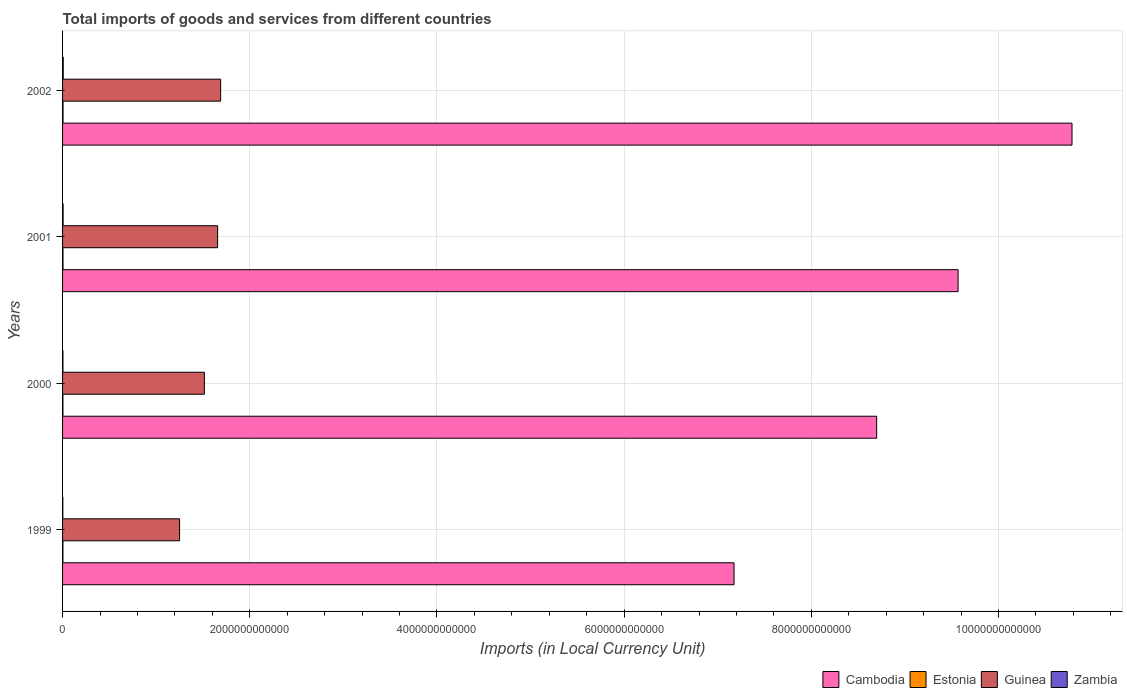How many different coloured bars are there?
Your answer should be very brief. 4. Are the number of bars per tick equal to the number of legend labels?
Your answer should be very brief. Yes. How many bars are there on the 1st tick from the top?
Provide a succinct answer. 4. What is the label of the 3rd group of bars from the top?
Your response must be concise. 2000. In how many cases, is the number of bars for a given year not equal to the number of legend labels?
Your response must be concise. 0. What is the Amount of goods and services imports in Zambia in 1999?
Give a very brief answer. 2.82e+09. Across all years, what is the maximum Amount of goods and services imports in Guinea?
Offer a very short reply. 1.69e+12. Across all years, what is the minimum Amount of goods and services imports in Estonia?
Your answer should be compact. 4.00e+09. In which year was the Amount of goods and services imports in Cambodia maximum?
Keep it short and to the point. 2002. What is the total Amount of goods and services imports in Estonia in the graph?
Your response must be concise. 1.77e+1. What is the difference between the Amount of goods and services imports in Estonia in 1999 and that in 2002?
Keep it short and to the point. -1.10e+09. What is the difference between the Amount of goods and services imports in Estonia in 1999 and the Amount of goods and services imports in Guinea in 2001?
Keep it short and to the point. -1.65e+12. What is the average Amount of goods and services imports in Zambia per year?
Keep it short and to the point. 4.93e+09. In the year 2001, what is the difference between the Amount of goods and services imports in Guinea and Amount of goods and services imports in Estonia?
Your answer should be compact. 1.65e+12. What is the ratio of the Amount of goods and services imports in Guinea in 1999 to that in 2002?
Provide a short and direct response. 0.74. Is the Amount of goods and services imports in Guinea in 1999 less than that in 2000?
Ensure brevity in your answer.  Yes. Is the difference between the Amount of goods and services imports in Guinea in 1999 and 2002 greater than the difference between the Amount of goods and services imports in Estonia in 1999 and 2002?
Your answer should be very brief. No. What is the difference between the highest and the second highest Amount of goods and services imports in Zambia?
Your answer should be very brief. 1.12e+09. What is the difference between the highest and the lowest Amount of goods and services imports in Cambodia?
Your answer should be very brief. 3.61e+12. In how many years, is the Amount of goods and services imports in Zambia greater than the average Amount of goods and services imports in Zambia taken over all years?
Offer a very short reply. 2. Is it the case that in every year, the sum of the Amount of goods and services imports in Guinea and Amount of goods and services imports in Estonia is greater than the sum of Amount of goods and services imports in Zambia and Amount of goods and services imports in Cambodia?
Give a very brief answer. Yes. What does the 2nd bar from the top in 2000 represents?
Keep it short and to the point. Guinea. What does the 4th bar from the bottom in 1999 represents?
Offer a terse response. Zambia. Is it the case that in every year, the sum of the Amount of goods and services imports in Guinea and Amount of goods and services imports in Zambia is greater than the Amount of goods and services imports in Estonia?
Provide a succinct answer. Yes. How many years are there in the graph?
Offer a very short reply. 4. What is the difference between two consecutive major ticks on the X-axis?
Offer a very short reply. 2.00e+12. Are the values on the major ticks of X-axis written in scientific E-notation?
Your response must be concise. No. Does the graph contain any zero values?
Your response must be concise. No. Where does the legend appear in the graph?
Provide a short and direct response. Bottom right. What is the title of the graph?
Give a very brief answer. Total imports of goods and services from different countries. What is the label or title of the X-axis?
Ensure brevity in your answer.  Imports (in Local Currency Unit). What is the label or title of the Y-axis?
Keep it short and to the point. Years. What is the Imports (in Local Currency Unit) in Cambodia in 1999?
Provide a short and direct response. 7.17e+12. What is the Imports (in Local Currency Unit) in Estonia in 1999?
Offer a terse response. 4.01e+09. What is the Imports (in Local Currency Unit) of Guinea in 1999?
Your answer should be compact. 1.25e+12. What is the Imports (in Local Currency Unit) of Zambia in 1999?
Provide a short and direct response. 2.82e+09. What is the Imports (in Local Currency Unit) in Cambodia in 2000?
Make the answer very short. 8.70e+12. What is the Imports (in Local Currency Unit) in Estonia in 2000?
Make the answer very short. 4.00e+09. What is the Imports (in Local Currency Unit) of Guinea in 2000?
Your answer should be very brief. 1.52e+12. What is the Imports (in Local Currency Unit) in Zambia in 2000?
Keep it short and to the point. 4.08e+09. What is the Imports (in Local Currency Unit) in Cambodia in 2001?
Provide a short and direct response. 9.57e+12. What is the Imports (in Local Currency Unit) of Estonia in 2001?
Offer a terse response. 4.56e+09. What is the Imports (in Local Currency Unit) in Guinea in 2001?
Keep it short and to the point. 1.66e+12. What is the Imports (in Local Currency Unit) of Zambia in 2001?
Provide a short and direct response. 5.85e+09. What is the Imports (in Local Currency Unit) in Cambodia in 2002?
Offer a very short reply. 1.08e+13. What is the Imports (in Local Currency Unit) in Estonia in 2002?
Provide a short and direct response. 5.11e+09. What is the Imports (in Local Currency Unit) in Guinea in 2002?
Provide a succinct answer. 1.69e+12. What is the Imports (in Local Currency Unit) of Zambia in 2002?
Your response must be concise. 6.97e+09. Across all years, what is the maximum Imports (in Local Currency Unit) in Cambodia?
Provide a succinct answer. 1.08e+13. Across all years, what is the maximum Imports (in Local Currency Unit) of Estonia?
Your answer should be very brief. 5.11e+09. Across all years, what is the maximum Imports (in Local Currency Unit) in Guinea?
Provide a succinct answer. 1.69e+12. Across all years, what is the maximum Imports (in Local Currency Unit) of Zambia?
Ensure brevity in your answer.  6.97e+09. Across all years, what is the minimum Imports (in Local Currency Unit) in Cambodia?
Make the answer very short. 7.17e+12. Across all years, what is the minimum Imports (in Local Currency Unit) of Estonia?
Make the answer very short. 4.00e+09. Across all years, what is the minimum Imports (in Local Currency Unit) in Guinea?
Your response must be concise. 1.25e+12. Across all years, what is the minimum Imports (in Local Currency Unit) of Zambia?
Offer a very short reply. 2.82e+09. What is the total Imports (in Local Currency Unit) in Cambodia in the graph?
Keep it short and to the point. 3.62e+13. What is the total Imports (in Local Currency Unit) of Estonia in the graph?
Offer a terse response. 1.77e+1. What is the total Imports (in Local Currency Unit) in Guinea in the graph?
Offer a very short reply. 6.11e+12. What is the total Imports (in Local Currency Unit) of Zambia in the graph?
Your answer should be compact. 1.97e+1. What is the difference between the Imports (in Local Currency Unit) in Cambodia in 1999 and that in 2000?
Offer a very short reply. -1.52e+12. What is the difference between the Imports (in Local Currency Unit) of Estonia in 1999 and that in 2000?
Keep it short and to the point. 1.12e+07. What is the difference between the Imports (in Local Currency Unit) in Guinea in 1999 and that in 2000?
Provide a succinct answer. -2.65e+11. What is the difference between the Imports (in Local Currency Unit) of Zambia in 1999 and that in 2000?
Provide a short and direct response. -1.26e+09. What is the difference between the Imports (in Local Currency Unit) in Cambodia in 1999 and that in 2001?
Offer a terse response. -2.39e+12. What is the difference between the Imports (in Local Currency Unit) of Estonia in 1999 and that in 2001?
Offer a terse response. -5.41e+08. What is the difference between the Imports (in Local Currency Unit) of Guinea in 1999 and that in 2001?
Keep it short and to the point. -4.07e+11. What is the difference between the Imports (in Local Currency Unit) of Zambia in 1999 and that in 2001?
Keep it short and to the point. -3.03e+09. What is the difference between the Imports (in Local Currency Unit) of Cambodia in 1999 and that in 2002?
Your answer should be very brief. -3.61e+12. What is the difference between the Imports (in Local Currency Unit) in Estonia in 1999 and that in 2002?
Make the answer very short. -1.10e+09. What is the difference between the Imports (in Local Currency Unit) of Guinea in 1999 and that in 2002?
Make the answer very short. -4.39e+11. What is the difference between the Imports (in Local Currency Unit) of Zambia in 1999 and that in 2002?
Provide a short and direct response. -4.15e+09. What is the difference between the Imports (in Local Currency Unit) in Cambodia in 2000 and that in 2001?
Make the answer very short. -8.70e+11. What is the difference between the Imports (in Local Currency Unit) of Estonia in 2000 and that in 2001?
Your response must be concise. -5.52e+08. What is the difference between the Imports (in Local Currency Unit) of Guinea in 2000 and that in 2001?
Your response must be concise. -1.41e+11. What is the difference between the Imports (in Local Currency Unit) in Zambia in 2000 and that in 2001?
Ensure brevity in your answer.  -1.76e+09. What is the difference between the Imports (in Local Currency Unit) of Cambodia in 2000 and that in 2002?
Offer a terse response. -2.09e+12. What is the difference between the Imports (in Local Currency Unit) of Estonia in 2000 and that in 2002?
Make the answer very short. -1.11e+09. What is the difference between the Imports (in Local Currency Unit) of Guinea in 2000 and that in 2002?
Your answer should be compact. -1.74e+11. What is the difference between the Imports (in Local Currency Unit) of Zambia in 2000 and that in 2002?
Your response must be concise. -2.89e+09. What is the difference between the Imports (in Local Currency Unit) in Cambodia in 2001 and that in 2002?
Your response must be concise. -1.22e+12. What is the difference between the Imports (in Local Currency Unit) of Estonia in 2001 and that in 2002?
Your answer should be very brief. -5.57e+08. What is the difference between the Imports (in Local Currency Unit) of Guinea in 2001 and that in 2002?
Give a very brief answer. -3.20e+1. What is the difference between the Imports (in Local Currency Unit) in Zambia in 2001 and that in 2002?
Make the answer very short. -1.12e+09. What is the difference between the Imports (in Local Currency Unit) of Cambodia in 1999 and the Imports (in Local Currency Unit) of Estonia in 2000?
Provide a short and direct response. 7.17e+12. What is the difference between the Imports (in Local Currency Unit) in Cambodia in 1999 and the Imports (in Local Currency Unit) in Guinea in 2000?
Your answer should be very brief. 5.66e+12. What is the difference between the Imports (in Local Currency Unit) of Cambodia in 1999 and the Imports (in Local Currency Unit) of Zambia in 2000?
Your answer should be very brief. 7.17e+12. What is the difference between the Imports (in Local Currency Unit) of Estonia in 1999 and the Imports (in Local Currency Unit) of Guinea in 2000?
Your answer should be very brief. -1.51e+12. What is the difference between the Imports (in Local Currency Unit) of Estonia in 1999 and the Imports (in Local Currency Unit) of Zambia in 2000?
Provide a succinct answer. -6.97e+07. What is the difference between the Imports (in Local Currency Unit) in Guinea in 1999 and the Imports (in Local Currency Unit) in Zambia in 2000?
Keep it short and to the point. 1.25e+12. What is the difference between the Imports (in Local Currency Unit) in Cambodia in 1999 and the Imports (in Local Currency Unit) in Estonia in 2001?
Offer a very short reply. 7.17e+12. What is the difference between the Imports (in Local Currency Unit) of Cambodia in 1999 and the Imports (in Local Currency Unit) of Guinea in 2001?
Your answer should be compact. 5.52e+12. What is the difference between the Imports (in Local Currency Unit) in Cambodia in 1999 and the Imports (in Local Currency Unit) in Zambia in 2001?
Keep it short and to the point. 7.17e+12. What is the difference between the Imports (in Local Currency Unit) in Estonia in 1999 and the Imports (in Local Currency Unit) in Guinea in 2001?
Keep it short and to the point. -1.65e+12. What is the difference between the Imports (in Local Currency Unit) of Estonia in 1999 and the Imports (in Local Currency Unit) of Zambia in 2001?
Provide a succinct answer. -1.83e+09. What is the difference between the Imports (in Local Currency Unit) in Guinea in 1999 and the Imports (in Local Currency Unit) in Zambia in 2001?
Ensure brevity in your answer.  1.24e+12. What is the difference between the Imports (in Local Currency Unit) of Cambodia in 1999 and the Imports (in Local Currency Unit) of Estonia in 2002?
Keep it short and to the point. 7.17e+12. What is the difference between the Imports (in Local Currency Unit) of Cambodia in 1999 and the Imports (in Local Currency Unit) of Guinea in 2002?
Give a very brief answer. 5.49e+12. What is the difference between the Imports (in Local Currency Unit) in Cambodia in 1999 and the Imports (in Local Currency Unit) in Zambia in 2002?
Offer a very short reply. 7.17e+12. What is the difference between the Imports (in Local Currency Unit) of Estonia in 1999 and the Imports (in Local Currency Unit) of Guinea in 2002?
Your answer should be compact. -1.68e+12. What is the difference between the Imports (in Local Currency Unit) in Estonia in 1999 and the Imports (in Local Currency Unit) in Zambia in 2002?
Give a very brief answer. -2.96e+09. What is the difference between the Imports (in Local Currency Unit) in Guinea in 1999 and the Imports (in Local Currency Unit) in Zambia in 2002?
Offer a terse response. 1.24e+12. What is the difference between the Imports (in Local Currency Unit) in Cambodia in 2000 and the Imports (in Local Currency Unit) in Estonia in 2001?
Make the answer very short. 8.69e+12. What is the difference between the Imports (in Local Currency Unit) in Cambodia in 2000 and the Imports (in Local Currency Unit) in Guinea in 2001?
Offer a very short reply. 7.04e+12. What is the difference between the Imports (in Local Currency Unit) in Cambodia in 2000 and the Imports (in Local Currency Unit) in Zambia in 2001?
Offer a terse response. 8.69e+12. What is the difference between the Imports (in Local Currency Unit) of Estonia in 2000 and the Imports (in Local Currency Unit) of Guinea in 2001?
Keep it short and to the point. -1.65e+12. What is the difference between the Imports (in Local Currency Unit) of Estonia in 2000 and the Imports (in Local Currency Unit) of Zambia in 2001?
Your answer should be compact. -1.85e+09. What is the difference between the Imports (in Local Currency Unit) of Guinea in 2000 and the Imports (in Local Currency Unit) of Zambia in 2001?
Your answer should be very brief. 1.51e+12. What is the difference between the Imports (in Local Currency Unit) of Cambodia in 2000 and the Imports (in Local Currency Unit) of Estonia in 2002?
Offer a very short reply. 8.69e+12. What is the difference between the Imports (in Local Currency Unit) of Cambodia in 2000 and the Imports (in Local Currency Unit) of Guinea in 2002?
Make the answer very short. 7.01e+12. What is the difference between the Imports (in Local Currency Unit) in Cambodia in 2000 and the Imports (in Local Currency Unit) in Zambia in 2002?
Your answer should be compact. 8.69e+12. What is the difference between the Imports (in Local Currency Unit) in Estonia in 2000 and the Imports (in Local Currency Unit) in Guinea in 2002?
Offer a terse response. -1.68e+12. What is the difference between the Imports (in Local Currency Unit) of Estonia in 2000 and the Imports (in Local Currency Unit) of Zambia in 2002?
Ensure brevity in your answer.  -2.97e+09. What is the difference between the Imports (in Local Currency Unit) in Guinea in 2000 and the Imports (in Local Currency Unit) in Zambia in 2002?
Your answer should be compact. 1.51e+12. What is the difference between the Imports (in Local Currency Unit) in Cambodia in 2001 and the Imports (in Local Currency Unit) in Estonia in 2002?
Offer a very short reply. 9.56e+12. What is the difference between the Imports (in Local Currency Unit) of Cambodia in 2001 and the Imports (in Local Currency Unit) of Guinea in 2002?
Ensure brevity in your answer.  7.88e+12. What is the difference between the Imports (in Local Currency Unit) in Cambodia in 2001 and the Imports (in Local Currency Unit) in Zambia in 2002?
Keep it short and to the point. 9.56e+12. What is the difference between the Imports (in Local Currency Unit) of Estonia in 2001 and the Imports (in Local Currency Unit) of Guinea in 2002?
Your answer should be compact. -1.68e+12. What is the difference between the Imports (in Local Currency Unit) in Estonia in 2001 and the Imports (in Local Currency Unit) in Zambia in 2002?
Provide a succinct answer. -2.41e+09. What is the difference between the Imports (in Local Currency Unit) of Guinea in 2001 and the Imports (in Local Currency Unit) of Zambia in 2002?
Provide a succinct answer. 1.65e+12. What is the average Imports (in Local Currency Unit) in Cambodia per year?
Your answer should be very brief. 9.06e+12. What is the average Imports (in Local Currency Unit) of Estonia per year?
Your response must be concise. 4.42e+09. What is the average Imports (in Local Currency Unit) of Guinea per year?
Your answer should be very brief. 1.53e+12. What is the average Imports (in Local Currency Unit) in Zambia per year?
Give a very brief answer. 4.93e+09. In the year 1999, what is the difference between the Imports (in Local Currency Unit) in Cambodia and Imports (in Local Currency Unit) in Estonia?
Provide a short and direct response. 7.17e+12. In the year 1999, what is the difference between the Imports (in Local Currency Unit) in Cambodia and Imports (in Local Currency Unit) in Guinea?
Give a very brief answer. 5.92e+12. In the year 1999, what is the difference between the Imports (in Local Currency Unit) in Cambodia and Imports (in Local Currency Unit) in Zambia?
Give a very brief answer. 7.17e+12. In the year 1999, what is the difference between the Imports (in Local Currency Unit) of Estonia and Imports (in Local Currency Unit) of Guinea?
Give a very brief answer. -1.25e+12. In the year 1999, what is the difference between the Imports (in Local Currency Unit) in Estonia and Imports (in Local Currency Unit) in Zambia?
Make the answer very short. 1.19e+09. In the year 1999, what is the difference between the Imports (in Local Currency Unit) of Guinea and Imports (in Local Currency Unit) of Zambia?
Your response must be concise. 1.25e+12. In the year 2000, what is the difference between the Imports (in Local Currency Unit) of Cambodia and Imports (in Local Currency Unit) of Estonia?
Keep it short and to the point. 8.69e+12. In the year 2000, what is the difference between the Imports (in Local Currency Unit) of Cambodia and Imports (in Local Currency Unit) of Guinea?
Your answer should be compact. 7.18e+12. In the year 2000, what is the difference between the Imports (in Local Currency Unit) of Cambodia and Imports (in Local Currency Unit) of Zambia?
Provide a succinct answer. 8.69e+12. In the year 2000, what is the difference between the Imports (in Local Currency Unit) of Estonia and Imports (in Local Currency Unit) of Guinea?
Your answer should be very brief. -1.51e+12. In the year 2000, what is the difference between the Imports (in Local Currency Unit) in Estonia and Imports (in Local Currency Unit) in Zambia?
Offer a terse response. -8.09e+07. In the year 2000, what is the difference between the Imports (in Local Currency Unit) in Guinea and Imports (in Local Currency Unit) in Zambia?
Provide a short and direct response. 1.51e+12. In the year 2001, what is the difference between the Imports (in Local Currency Unit) of Cambodia and Imports (in Local Currency Unit) of Estonia?
Provide a short and direct response. 9.56e+12. In the year 2001, what is the difference between the Imports (in Local Currency Unit) in Cambodia and Imports (in Local Currency Unit) in Guinea?
Make the answer very short. 7.91e+12. In the year 2001, what is the difference between the Imports (in Local Currency Unit) of Cambodia and Imports (in Local Currency Unit) of Zambia?
Your answer should be very brief. 9.56e+12. In the year 2001, what is the difference between the Imports (in Local Currency Unit) of Estonia and Imports (in Local Currency Unit) of Guinea?
Ensure brevity in your answer.  -1.65e+12. In the year 2001, what is the difference between the Imports (in Local Currency Unit) in Estonia and Imports (in Local Currency Unit) in Zambia?
Give a very brief answer. -1.29e+09. In the year 2001, what is the difference between the Imports (in Local Currency Unit) of Guinea and Imports (in Local Currency Unit) of Zambia?
Your answer should be compact. 1.65e+12. In the year 2002, what is the difference between the Imports (in Local Currency Unit) of Cambodia and Imports (in Local Currency Unit) of Estonia?
Offer a terse response. 1.08e+13. In the year 2002, what is the difference between the Imports (in Local Currency Unit) in Cambodia and Imports (in Local Currency Unit) in Guinea?
Your answer should be very brief. 9.10e+12. In the year 2002, what is the difference between the Imports (in Local Currency Unit) of Cambodia and Imports (in Local Currency Unit) of Zambia?
Give a very brief answer. 1.08e+13. In the year 2002, what is the difference between the Imports (in Local Currency Unit) of Estonia and Imports (in Local Currency Unit) of Guinea?
Offer a very short reply. -1.68e+12. In the year 2002, what is the difference between the Imports (in Local Currency Unit) of Estonia and Imports (in Local Currency Unit) of Zambia?
Offer a very short reply. -1.86e+09. In the year 2002, what is the difference between the Imports (in Local Currency Unit) in Guinea and Imports (in Local Currency Unit) in Zambia?
Your response must be concise. 1.68e+12. What is the ratio of the Imports (in Local Currency Unit) in Cambodia in 1999 to that in 2000?
Offer a terse response. 0.82. What is the ratio of the Imports (in Local Currency Unit) in Estonia in 1999 to that in 2000?
Give a very brief answer. 1. What is the ratio of the Imports (in Local Currency Unit) in Guinea in 1999 to that in 2000?
Provide a succinct answer. 0.83. What is the ratio of the Imports (in Local Currency Unit) in Zambia in 1999 to that in 2000?
Give a very brief answer. 0.69. What is the ratio of the Imports (in Local Currency Unit) in Cambodia in 1999 to that in 2001?
Give a very brief answer. 0.75. What is the ratio of the Imports (in Local Currency Unit) in Estonia in 1999 to that in 2001?
Make the answer very short. 0.88. What is the ratio of the Imports (in Local Currency Unit) of Guinea in 1999 to that in 2001?
Offer a very short reply. 0.75. What is the ratio of the Imports (in Local Currency Unit) of Zambia in 1999 to that in 2001?
Provide a succinct answer. 0.48. What is the ratio of the Imports (in Local Currency Unit) of Cambodia in 1999 to that in 2002?
Provide a short and direct response. 0.67. What is the ratio of the Imports (in Local Currency Unit) of Estonia in 1999 to that in 2002?
Offer a very short reply. 0.79. What is the ratio of the Imports (in Local Currency Unit) of Guinea in 1999 to that in 2002?
Provide a succinct answer. 0.74. What is the ratio of the Imports (in Local Currency Unit) in Zambia in 1999 to that in 2002?
Ensure brevity in your answer.  0.41. What is the ratio of the Imports (in Local Currency Unit) in Estonia in 2000 to that in 2001?
Offer a very short reply. 0.88. What is the ratio of the Imports (in Local Currency Unit) in Guinea in 2000 to that in 2001?
Your answer should be compact. 0.91. What is the ratio of the Imports (in Local Currency Unit) in Zambia in 2000 to that in 2001?
Make the answer very short. 0.7. What is the ratio of the Imports (in Local Currency Unit) in Cambodia in 2000 to that in 2002?
Your response must be concise. 0.81. What is the ratio of the Imports (in Local Currency Unit) in Estonia in 2000 to that in 2002?
Offer a terse response. 0.78. What is the ratio of the Imports (in Local Currency Unit) of Guinea in 2000 to that in 2002?
Provide a short and direct response. 0.9. What is the ratio of the Imports (in Local Currency Unit) of Zambia in 2000 to that in 2002?
Your answer should be compact. 0.59. What is the ratio of the Imports (in Local Currency Unit) of Cambodia in 2001 to that in 2002?
Your answer should be compact. 0.89. What is the ratio of the Imports (in Local Currency Unit) of Estonia in 2001 to that in 2002?
Keep it short and to the point. 0.89. What is the ratio of the Imports (in Local Currency Unit) of Zambia in 2001 to that in 2002?
Make the answer very short. 0.84. What is the difference between the highest and the second highest Imports (in Local Currency Unit) in Cambodia?
Offer a very short reply. 1.22e+12. What is the difference between the highest and the second highest Imports (in Local Currency Unit) in Estonia?
Ensure brevity in your answer.  5.57e+08. What is the difference between the highest and the second highest Imports (in Local Currency Unit) of Guinea?
Offer a terse response. 3.20e+1. What is the difference between the highest and the second highest Imports (in Local Currency Unit) of Zambia?
Your answer should be very brief. 1.12e+09. What is the difference between the highest and the lowest Imports (in Local Currency Unit) in Cambodia?
Your response must be concise. 3.61e+12. What is the difference between the highest and the lowest Imports (in Local Currency Unit) in Estonia?
Give a very brief answer. 1.11e+09. What is the difference between the highest and the lowest Imports (in Local Currency Unit) of Guinea?
Keep it short and to the point. 4.39e+11. What is the difference between the highest and the lowest Imports (in Local Currency Unit) in Zambia?
Provide a succinct answer. 4.15e+09. 